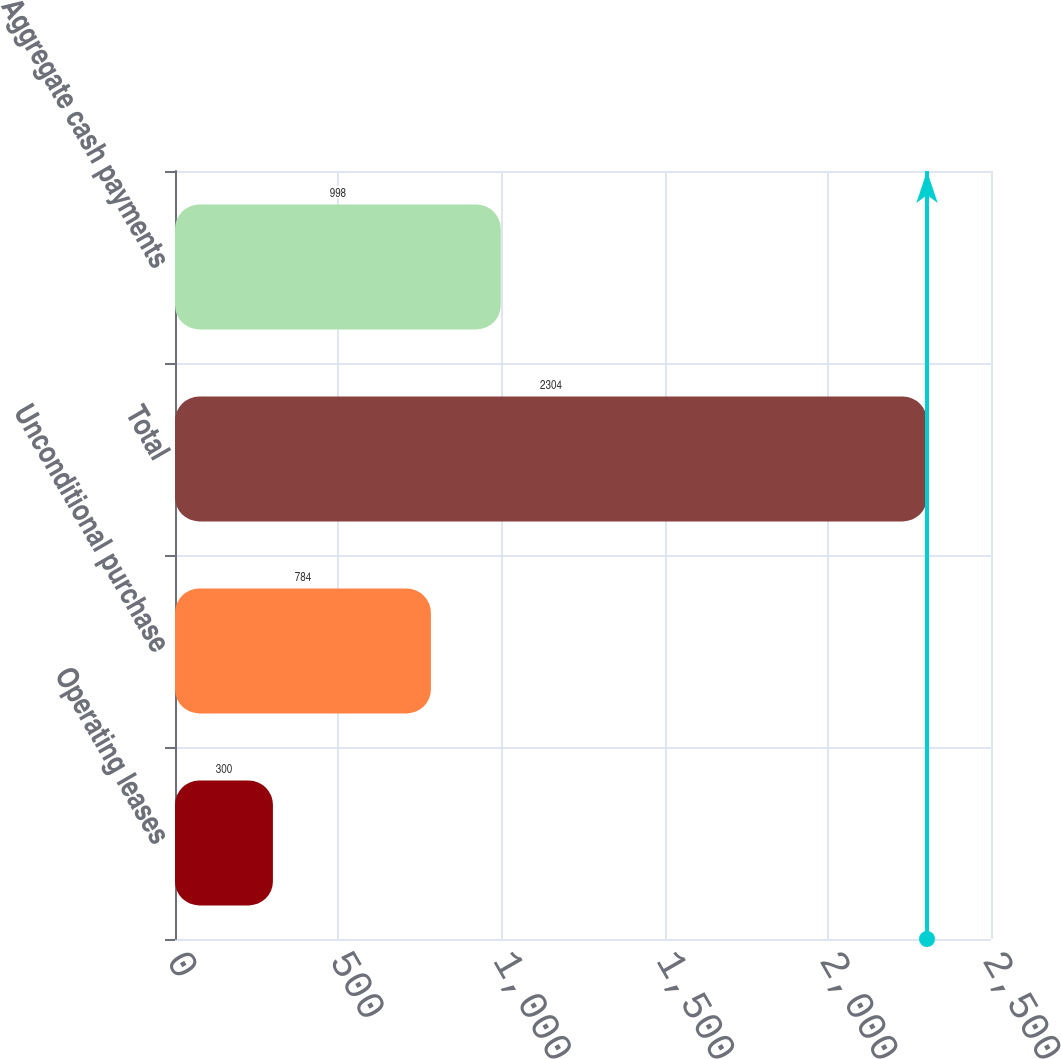Convert chart. <chart><loc_0><loc_0><loc_500><loc_500><bar_chart><fcel>Operating leases<fcel>Unconditional purchase<fcel>Total<fcel>Aggregate cash payments<nl><fcel>300<fcel>784<fcel>2304<fcel>998<nl></chart> 